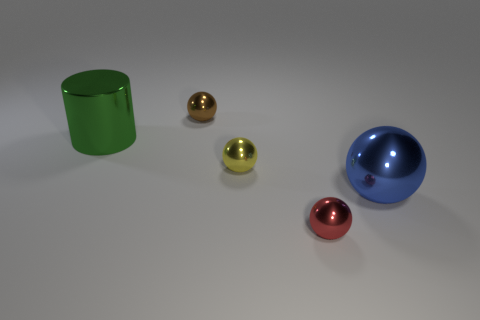Subtract 1 spheres. How many spheres are left? 3 Subtract all small balls. How many balls are left? 1 Subtract all brown spheres. How many spheres are left? 3 Add 3 cylinders. How many objects exist? 8 Subtract all gray balls. Subtract all cyan blocks. How many balls are left? 4 Subtract all spheres. How many objects are left? 1 Add 5 yellow rubber spheres. How many yellow rubber spheres exist? 5 Subtract 0 yellow cubes. How many objects are left? 5 Subtract all metallic cylinders. Subtract all small brown spheres. How many objects are left? 3 Add 3 brown spheres. How many brown spheres are left? 4 